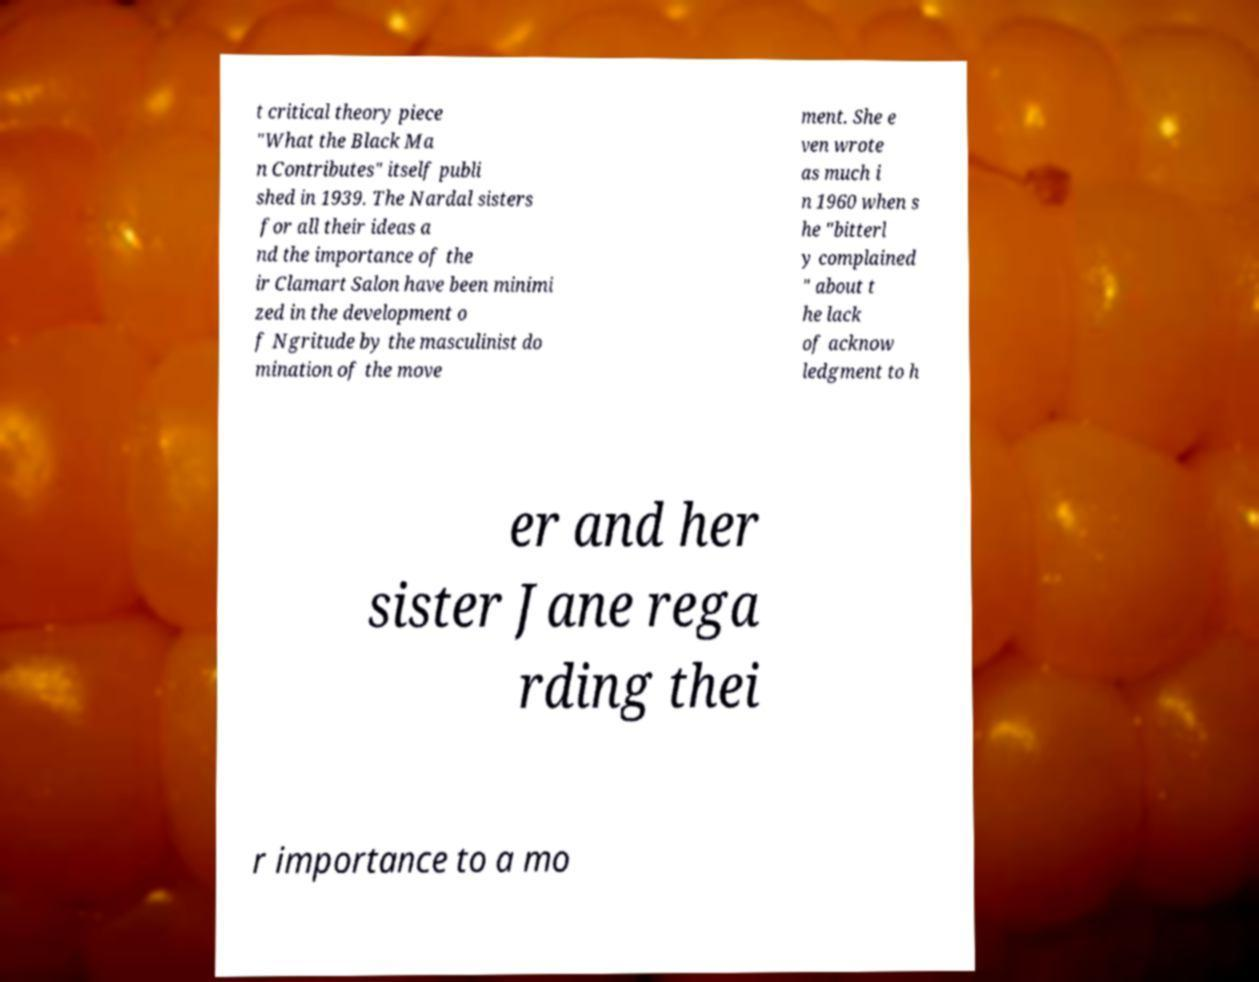There's text embedded in this image that I need extracted. Can you transcribe it verbatim? t critical theory piece "What the Black Ma n Contributes" itself publi shed in 1939. The Nardal sisters for all their ideas a nd the importance of the ir Clamart Salon have been minimi zed in the development o f Ngritude by the masculinist do mination of the move ment. She e ven wrote as much i n 1960 when s he "bitterl y complained " about t he lack of acknow ledgment to h er and her sister Jane rega rding thei r importance to a mo 